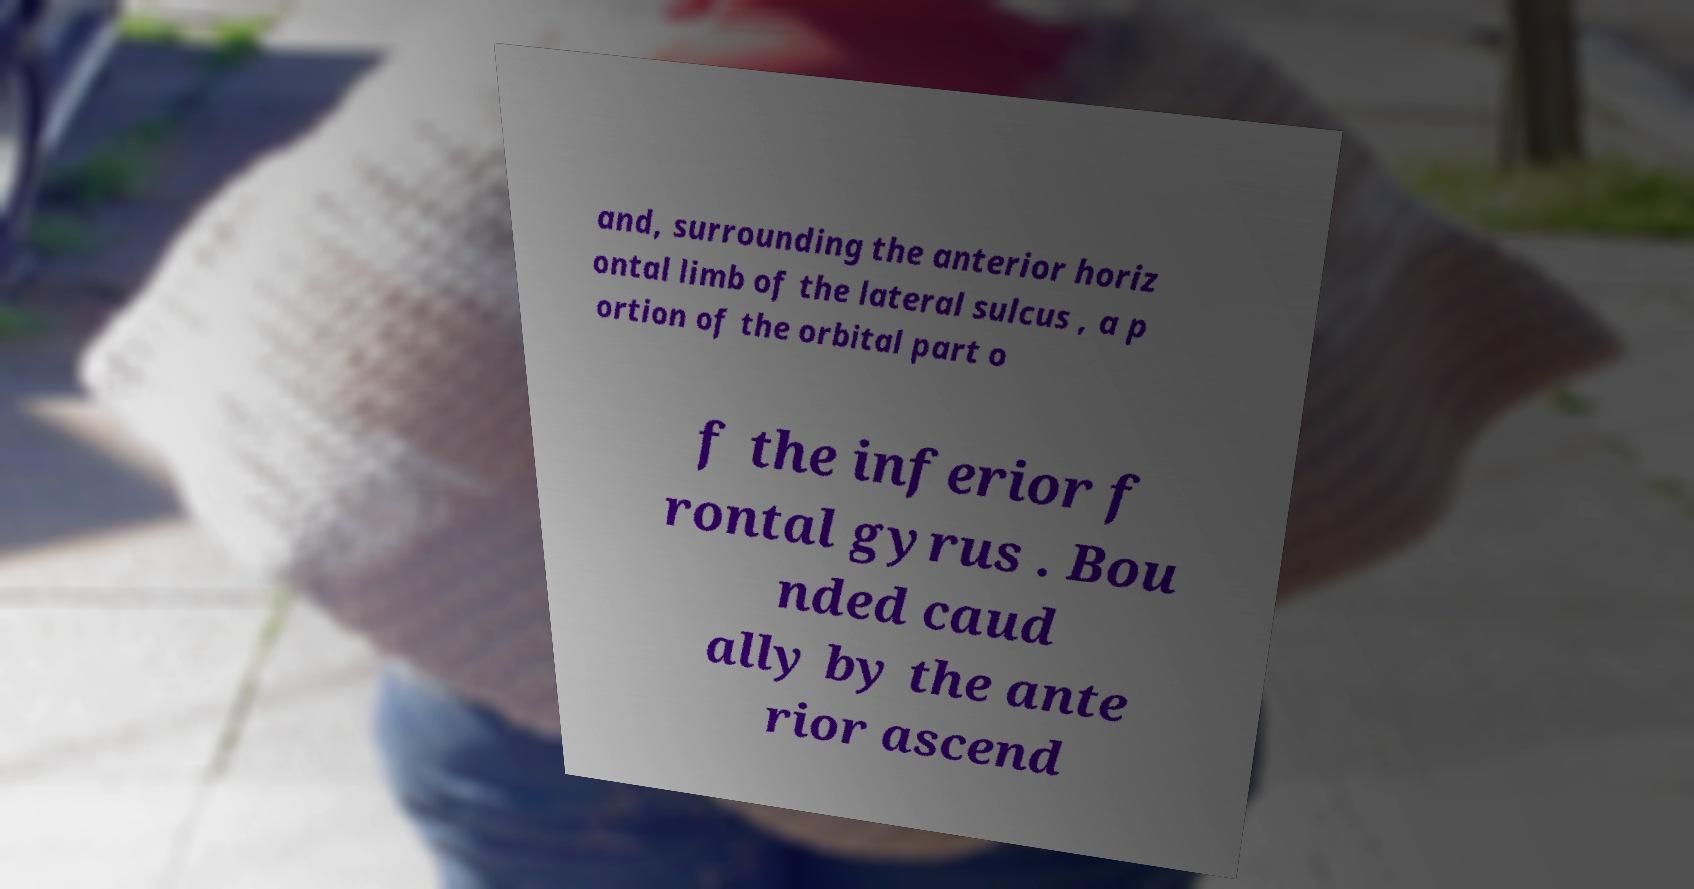For documentation purposes, I need the text within this image transcribed. Could you provide that? and, surrounding the anterior horiz ontal limb of the lateral sulcus , a p ortion of the orbital part o f the inferior f rontal gyrus . Bou nded caud ally by the ante rior ascend 